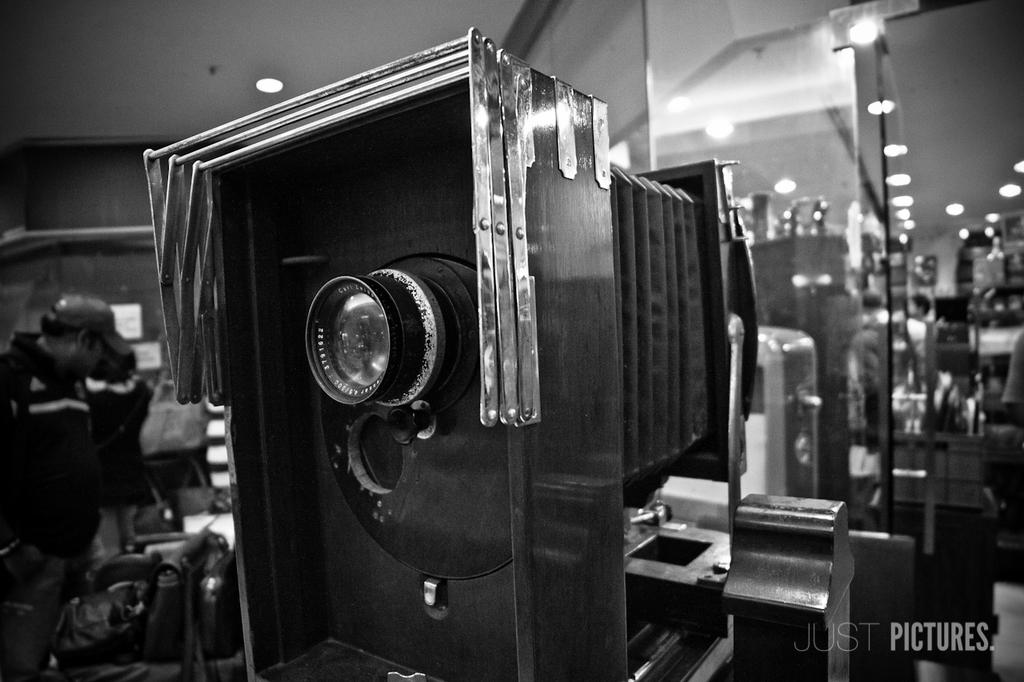What object is the main focus of the image? There is a black camera in the image. Can you describe the person in the image? There is a person standing on the left side of the image. What is on the right side of the image? There is a mirror on the right side of the image. What architectural feature is visible in the image? There is a roof visible in the image. What can be seen providing illumination in the image? There is a light visible in the image. What type of shoe is the person wearing in the image? There is no shoe visible in the image; only the person's body is shown. Can you hear any bells ringing in the image? There are no bells present in the image. How many pies are visible in the image? There are no pies present in the image. 